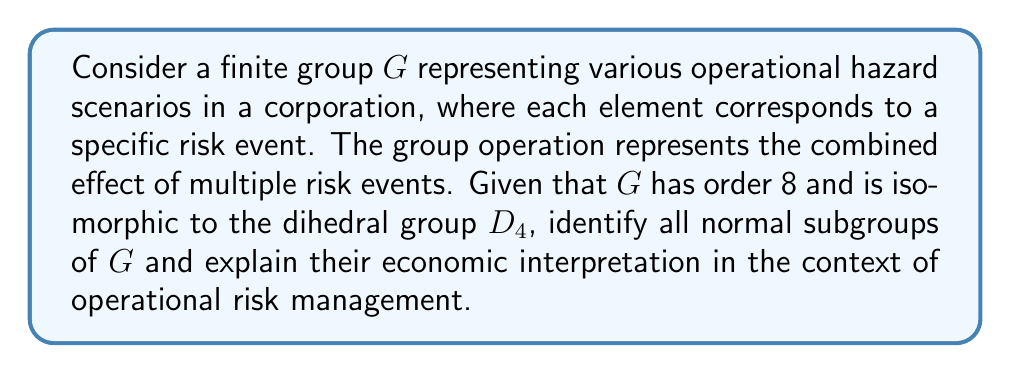Can you answer this question? To solve this problem, we'll follow these steps:

1) Recall the structure of $D_4$:
   $D_4 = \{e, r, r^2, r^3, s, sr, sr^2, sr^3\}$
   where $r$ represents a 90-degree rotation and $s$ represents a reflection.

2) The normal subgroups of $D_4$ are:
   - $\{e\}$ (trivial subgroup)
   - $\{e, r^2\}$
   - $\{e, r, r^2, r^3\}$
   - $D_4$ itself

3) Economic interpretation:

   a) $\{e\}$: This represents the scenario with no operational hazards. It's always a normal subgroup and corresponds to the ideal state of no risk.

   b) $\{e, r^2\}$: This subgroup represents a set of risk events that, when combined, either result in no effect (e) or a significant impact (r^2, which is a 180-degree rotation in $D_4$). Economically, this could represent a pair of offsetting risks or a risk with binary outcomes.

   c) $\{e, r, r^2, r^3\}$: This cyclic subgroup of order 4 represents a set of risk events that have cumulative effects. Each application of $r$ could represent an incremental increase in the severity of the operational risk. This might model scenarios where risks compound over time or through repeated occurrences.

   d) $D_4$ itself: This represents the full set of all possible risk scenarios in this model.

4) The normality of these subgroups implies that these risk categories are invariant under the action of any other risk event. In other words, these risk categories remain relevant and maintain their structure regardless of other operational hazards that may occur.

5) From a risk management perspective, identifying these normal subgroups allows the corporation to focus on key risk categories that behave consistently under various scenarios, potentially simplifying risk assessment and mitigation strategies.
Answer: The normal subgroups of $G \cong D_4$ are:
1) $\{e\}$
2) $\{e, r^2\}$
3) $\{e, r, r^2, r^3\}$
4) $G$ itself

These represent, respectively: the no-risk scenario, a binary risk category, a cumulative risk category, and the full risk landscape. Their normality implies invariance under other risk events, providing stable categories for risk management. 